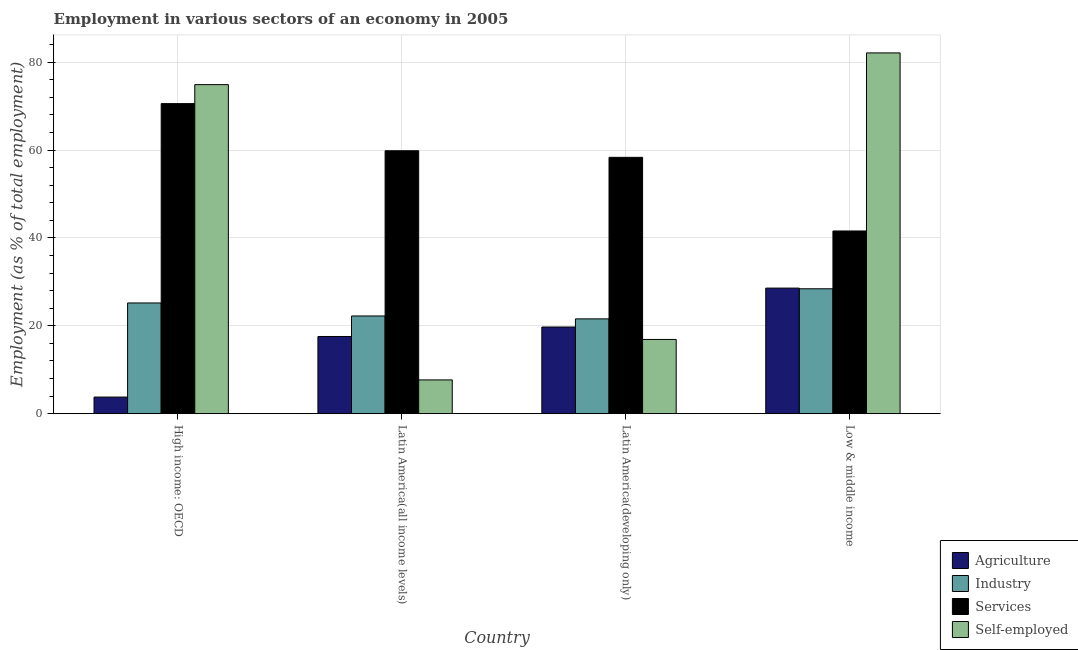How many groups of bars are there?
Provide a short and direct response. 4. How many bars are there on the 4th tick from the left?
Offer a very short reply. 4. What is the label of the 3rd group of bars from the left?
Your answer should be very brief. Latin America(developing only). In how many cases, is the number of bars for a given country not equal to the number of legend labels?
Make the answer very short. 0. What is the percentage of workers in industry in Latin America(all income levels)?
Make the answer very short. 22.24. Across all countries, what is the maximum percentage of workers in agriculture?
Offer a very short reply. 28.58. Across all countries, what is the minimum percentage of workers in services?
Give a very brief answer. 41.58. In which country was the percentage of workers in agriculture maximum?
Offer a terse response. Low & middle income. In which country was the percentage of workers in agriculture minimum?
Offer a terse response. High income: OECD. What is the total percentage of workers in industry in the graph?
Offer a terse response. 97.46. What is the difference between the percentage of self employed workers in Latin America(all income levels) and that in Latin America(developing only)?
Make the answer very short. -9.21. What is the difference between the percentage of workers in industry in High income: OECD and the percentage of workers in agriculture in Latin America(all income levels)?
Provide a short and direct response. 7.63. What is the average percentage of workers in services per country?
Your answer should be very brief. 57.58. What is the difference between the percentage of self employed workers and percentage of workers in services in High income: OECD?
Ensure brevity in your answer.  4.32. In how many countries, is the percentage of workers in agriculture greater than 36 %?
Keep it short and to the point. 0. What is the ratio of the percentage of workers in industry in Latin America(all income levels) to that in Latin America(developing only)?
Give a very brief answer. 1.03. Is the difference between the percentage of self employed workers in High income: OECD and Latin America(developing only) greater than the difference between the percentage of workers in services in High income: OECD and Latin America(developing only)?
Provide a succinct answer. Yes. What is the difference between the highest and the second highest percentage of workers in industry?
Offer a very short reply. 3.23. What is the difference between the highest and the lowest percentage of workers in services?
Offer a very short reply. 28.98. Is the sum of the percentage of workers in services in Latin America(all income levels) and Low & middle income greater than the maximum percentage of workers in agriculture across all countries?
Your answer should be very brief. Yes. Is it the case that in every country, the sum of the percentage of workers in industry and percentage of workers in services is greater than the sum of percentage of workers in agriculture and percentage of self employed workers?
Keep it short and to the point. No. What does the 3rd bar from the left in Low & middle income represents?
Ensure brevity in your answer.  Services. What does the 3rd bar from the right in Latin America(developing only) represents?
Provide a succinct answer. Industry. Is it the case that in every country, the sum of the percentage of workers in agriculture and percentage of workers in industry is greater than the percentage of workers in services?
Provide a short and direct response. No. How many bars are there?
Provide a short and direct response. 16. Are all the bars in the graph horizontal?
Make the answer very short. No. How many countries are there in the graph?
Make the answer very short. 4. What is the difference between two consecutive major ticks on the Y-axis?
Ensure brevity in your answer.  20. Does the graph contain any zero values?
Provide a succinct answer. No. How many legend labels are there?
Keep it short and to the point. 4. What is the title of the graph?
Keep it short and to the point. Employment in various sectors of an economy in 2005. What is the label or title of the Y-axis?
Make the answer very short. Employment (as % of total employment). What is the Employment (as % of total employment) in Agriculture in High income: OECD?
Ensure brevity in your answer.  3.79. What is the Employment (as % of total employment) of Industry in High income: OECD?
Ensure brevity in your answer.  25.2. What is the Employment (as % of total employment) of Services in High income: OECD?
Give a very brief answer. 70.56. What is the Employment (as % of total employment) of Self-employed in High income: OECD?
Provide a short and direct response. 74.88. What is the Employment (as % of total employment) of Agriculture in Latin America(all income levels)?
Provide a succinct answer. 17.58. What is the Employment (as % of total employment) of Industry in Latin America(all income levels)?
Keep it short and to the point. 22.24. What is the Employment (as % of total employment) in Services in Latin America(all income levels)?
Give a very brief answer. 59.84. What is the Employment (as % of total employment) of Self-employed in Latin America(all income levels)?
Your answer should be compact. 7.69. What is the Employment (as % of total employment) in Agriculture in Latin America(developing only)?
Your response must be concise. 19.73. What is the Employment (as % of total employment) of Industry in Latin America(developing only)?
Give a very brief answer. 21.59. What is the Employment (as % of total employment) in Services in Latin America(developing only)?
Your answer should be compact. 58.34. What is the Employment (as % of total employment) in Self-employed in Latin America(developing only)?
Provide a succinct answer. 16.9. What is the Employment (as % of total employment) of Agriculture in Low & middle income?
Keep it short and to the point. 28.58. What is the Employment (as % of total employment) of Industry in Low & middle income?
Your answer should be compact. 28.43. What is the Employment (as % of total employment) of Services in Low & middle income?
Offer a terse response. 41.58. What is the Employment (as % of total employment) of Self-employed in Low & middle income?
Your answer should be compact. 82.1. Across all countries, what is the maximum Employment (as % of total employment) in Agriculture?
Keep it short and to the point. 28.58. Across all countries, what is the maximum Employment (as % of total employment) in Industry?
Keep it short and to the point. 28.43. Across all countries, what is the maximum Employment (as % of total employment) of Services?
Your response must be concise. 70.56. Across all countries, what is the maximum Employment (as % of total employment) in Self-employed?
Provide a short and direct response. 82.1. Across all countries, what is the minimum Employment (as % of total employment) of Agriculture?
Keep it short and to the point. 3.79. Across all countries, what is the minimum Employment (as % of total employment) of Industry?
Your answer should be very brief. 21.59. Across all countries, what is the minimum Employment (as % of total employment) in Services?
Offer a terse response. 41.58. Across all countries, what is the minimum Employment (as % of total employment) in Self-employed?
Keep it short and to the point. 7.69. What is the total Employment (as % of total employment) in Agriculture in the graph?
Offer a terse response. 69.69. What is the total Employment (as % of total employment) of Industry in the graph?
Keep it short and to the point. 97.46. What is the total Employment (as % of total employment) in Services in the graph?
Keep it short and to the point. 230.32. What is the total Employment (as % of total employment) of Self-employed in the graph?
Your response must be concise. 181.58. What is the difference between the Employment (as % of total employment) in Agriculture in High income: OECD and that in Latin America(all income levels)?
Ensure brevity in your answer.  -13.78. What is the difference between the Employment (as % of total employment) of Industry in High income: OECD and that in Latin America(all income levels)?
Offer a very short reply. 2.96. What is the difference between the Employment (as % of total employment) of Services in High income: OECD and that in Latin America(all income levels)?
Give a very brief answer. 10.72. What is the difference between the Employment (as % of total employment) of Self-employed in High income: OECD and that in Latin America(all income levels)?
Provide a succinct answer. 67.19. What is the difference between the Employment (as % of total employment) of Agriculture in High income: OECD and that in Latin America(developing only)?
Ensure brevity in your answer.  -15.94. What is the difference between the Employment (as % of total employment) in Industry in High income: OECD and that in Latin America(developing only)?
Offer a terse response. 3.62. What is the difference between the Employment (as % of total employment) of Services in High income: OECD and that in Latin America(developing only)?
Give a very brief answer. 12.22. What is the difference between the Employment (as % of total employment) in Self-employed in High income: OECD and that in Latin America(developing only)?
Your response must be concise. 57.98. What is the difference between the Employment (as % of total employment) in Agriculture in High income: OECD and that in Low & middle income?
Offer a terse response. -24.79. What is the difference between the Employment (as % of total employment) of Industry in High income: OECD and that in Low & middle income?
Your answer should be very brief. -3.23. What is the difference between the Employment (as % of total employment) in Services in High income: OECD and that in Low & middle income?
Provide a short and direct response. 28.98. What is the difference between the Employment (as % of total employment) in Self-employed in High income: OECD and that in Low & middle income?
Provide a succinct answer. -7.22. What is the difference between the Employment (as % of total employment) in Agriculture in Latin America(all income levels) and that in Latin America(developing only)?
Your response must be concise. -2.16. What is the difference between the Employment (as % of total employment) of Industry in Latin America(all income levels) and that in Latin America(developing only)?
Keep it short and to the point. 0.66. What is the difference between the Employment (as % of total employment) in Services in Latin America(all income levels) and that in Latin America(developing only)?
Make the answer very short. 1.5. What is the difference between the Employment (as % of total employment) of Self-employed in Latin America(all income levels) and that in Latin America(developing only)?
Provide a succinct answer. -9.21. What is the difference between the Employment (as % of total employment) of Agriculture in Latin America(all income levels) and that in Low & middle income?
Provide a succinct answer. -11.01. What is the difference between the Employment (as % of total employment) in Industry in Latin America(all income levels) and that in Low & middle income?
Your answer should be compact. -6.19. What is the difference between the Employment (as % of total employment) in Services in Latin America(all income levels) and that in Low & middle income?
Your answer should be compact. 18.25. What is the difference between the Employment (as % of total employment) of Self-employed in Latin America(all income levels) and that in Low & middle income?
Your response must be concise. -74.4. What is the difference between the Employment (as % of total employment) of Agriculture in Latin America(developing only) and that in Low & middle income?
Keep it short and to the point. -8.85. What is the difference between the Employment (as % of total employment) of Industry in Latin America(developing only) and that in Low & middle income?
Offer a terse response. -6.85. What is the difference between the Employment (as % of total employment) of Services in Latin America(developing only) and that in Low & middle income?
Offer a very short reply. 16.75. What is the difference between the Employment (as % of total employment) in Self-employed in Latin America(developing only) and that in Low & middle income?
Your answer should be very brief. -65.19. What is the difference between the Employment (as % of total employment) of Agriculture in High income: OECD and the Employment (as % of total employment) of Industry in Latin America(all income levels)?
Keep it short and to the point. -18.45. What is the difference between the Employment (as % of total employment) in Agriculture in High income: OECD and the Employment (as % of total employment) in Services in Latin America(all income levels)?
Your answer should be very brief. -56.04. What is the difference between the Employment (as % of total employment) of Agriculture in High income: OECD and the Employment (as % of total employment) of Self-employed in Latin America(all income levels)?
Offer a terse response. -3.9. What is the difference between the Employment (as % of total employment) in Industry in High income: OECD and the Employment (as % of total employment) in Services in Latin America(all income levels)?
Ensure brevity in your answer.  -34.63. What is the difference between the Employment (as % of total employment) in Industry in High income: OECD and the Employment (as % of total employment) in Self-employed in Latin America(all income levels)?
Your answer should be compact. 17.51. What is the difference between the Employment (as % of total employment) of Services in High income: OECD and the Employment (as % of total employment) of Self-employed in Latin America(all income levels)?
Your answer should be very brief. 62.87. What is the difference between the Employment (as % of total employment) in Agriculture in High income: OECD and the Employment (as % of total employment) in Industry in Latin America(developing only)?
Give a very brief answer. -17.79. What is the difference between the Employment (as % of total employment) of Agriculture in High income: OECD and the Employment (as % of total employment) of Services in Latin America(developing only)?
Offer a very short reply. -54.54. What is the difference between the Employment (as % of total employment) in Agriculture in High income: OECD and the Employment (as % of total employment) in Self-employed in Latin America(developing only)?
Offer a terse response. -13.11. What is the difference between the Employment (as % of total employment) of Industry in High income: OECD and the Employment (as % of total employment) of Services in Latin America(developing only)?
Keep it short and to the point. -33.13. What is the difference between the Employment (as % of total employment) of Industry in High income: OECD and the Employment (as % of total employment) of Self-employed in Latin America(developing only)?
Offer a terse response. 8.3. What is the difference between the Employment (as % of total employment) in Services in High income: OECD and the Employment (as % of total employment) in Self-employed in Latin America(developing only)?
Make the answer very short. 53.66. What is the difference between the Employment (as % of total employment) in Agriculture in High income: OECD and the Employment (as % of total employment) in Industry in Low & middle income?
Your response must be concise. -24.64. What is the difference between the Employment (as % of total employment) in Agriculture in High income: OECD and the Employment (as % of total employment) in Services in Low & middle income?
Your response must be concise. -37.79. What is the difference between the Employment (as % of total employment) of Agriculture in High income: OECD and the Employment (as % of total employment) of Self-employed in Low & middle income?
Your answer should be compact. -78.3. What is the difference between the Employment (as % of total employment) in Industry in High income: OECD and the Employment (as % of total employment) in Services in Low & middle income?
Ensure brevity in your answer.  -16.38. What is the difference between the Employment (as % of total employment) of Industry in High income: OECD and the Employment (as % of total employment) of Self-employed in Low & middle income?
Give a very brief answer. -56.89. What is the difference between the Employment (as % of total employment) in Services in High income: OECD and the Employment (as % of total employment) in Self-employed in Low & middle income?
Provide a short and direct response. -11.54. What is the difference between the Employment (as % of total employment) in Agriculture in Latin America(all income levels) and the Employment (as % of total employment) in Industry in Latin America(developing only)?
Keep it short and to the point. -4.01. What is the difference between the Employment (as % of total employment) in Agriculture in Latin America(all income levels) and the Employment (as % of total employment) in Services in Latin America(developing only)?
Your answer should be very brief. -40.76. What is the difference between the Employment (as % of total employment) in Agriculture in Latin America(all income levels) and the Employment (as % of total employment) in Self-employed in Latin America(developing only)?
Your response must be concise. 0.67. What is the difference between the Employment (as % of total employment) of Industry in Latin America(all income levels) and the Employment (as % of total employment) of Services in Latin America(developing only)?
Your response must be concise. -36.09. What is the difference between the Employment (as % of total employment) of Industry in Latin America(all income levels) and the Employment (as % of total employment) of Self-employed in Latin America(developing only)?
Your response must be concise. 5.34. What is the difference between the Employment (as % of total employment) in Services in Latin America(all income levels) and the Employment (as % of total employment) in Self-employed in Latin America(developing only)?
Make the answer very short. 42.93. What is the difference between the Employment (as % of total employment) of Agriculture in Latin America(all income levels) and the Employment (as % of total employment) of Industry in Low & middle income?
Offer a very short reply. -10.86. What is the difference between the Employment (as % of total employment) of Agriculture in Latin America(all income levels) and the Employment (as % of total employment) of Services in Low & middle income?
Make the answer very short. -24.01. What is the difference between the Employment (as % of total employment) of Agriculture in Latin America(all income levels) and the Employment (as % of total employment) of Self-employed in Low & middle income?
Ensure brevity in your answer.  -64.52. What is the difference between the Employment (as % of total employment) of Industry in Latin America(all income levels) and the Employment (as % of total employment) of Services in Low & middle income?
Offer a terse response. -19.34. What is the difference between the Employment (as % of total employment) in Industry in Latin America(all income levels) and the Employment (as % of total employment) in Self-employed in Low & middle income?
Your answer should be very brief. -59.85. What is the difference between the Employment (as % of total employment) in Services in Latin America(all income levels) and the Employment (as % of total employment) in Self-employed in Low & middle income?
Offer a terse response. -22.26. What is the difference between the Employment (as % of total employment) in Agriculture in Latin America(developing only) and the Employment (as % of total employment) in Industry in Low & middle income?
Give a very brief answer. -8.7. What is the difference between the Employment (as % of total employment) in Agriculture in Latin America(developing only) and the Employment (as % of total employment) in Services in Low & middle income?
Make the answer very short. -21.85. What is the difference between the Employment (as % of total employment) in Agriculture in Latin America(developing only) and the Employment (as % of total employment) in Self-employed in Low & middle income?
Provide a succinct answer. -62.36. What is the difference between the Employment (as % of total employment) of Industry in Latin America(developing only) and the Employment (as % of total employment) of Services in Low & middle income?
Your response must be concise. -20. What is the difference between the Employment (as % of total employment) of Industry in Latin America(developing only) and the Employment (as % of total employment) of Self-employed in Low & middle income?
Offer a very short reply. -60.51. What is the difference between the Employment (as % of total employment) of Services in Latin America(developing only) and the Employment (as % of total employment) of Self-employed in Low & middle income?
Ensure brevity in your answer.  -23.76. What is the average Employment (as % of total employment) of Agriculture per country?
Your answer should be compact. 17.42. What is the average Employment (as % of total employment) of Industry per country?
Your response must be concise. 24.37. What is the average Employment (as % of total employment) in Services per country?
Ensure brevity in your answer.  57.58. What is the average Employment (as % of total employment) in Self-employed per country?
Your response must be concise. 45.39. What is the difference between the Employment (as % of total employment) of Agriculture and Employment (as % of total employment) of Industry in High income: OECD?
Keep it short and to the point. -21.41. What is the difference between the Employment (as % of total employment) of Agriculture and Employment (as % of total employment) of Services in High income: OECD?
Your answer should be very brief. -66.77. What is the difference between the Employment (as % of total employment) in Agriculture and Employment (as % of total employment) in Self-employed in High income: OECD?
Provide a short and direct response. -71.09. What is the difference between the Employment (as % of total employment) of Industry and Employment (as % of total employment) of Services in High income: OECD?
Your response must be concise. -45.36. What is the difference between the Employment (as % of total employment) in Industry and Employment (as % of total employment) in Self-employed in High income: OECD?
Your answer should be compact. -49.68. What is the difference between the Employment (as % of total employment) of Services and Employment (as % of total employment) of Self-employed in High income: OECD?
Ensure brevity in your answer.  -4.32. What is the difference between the Employment (as % of total employment) in Agriculture and Employment (as % of total employment) in Industry in Latin America(all income levels)?
Provide a succinct answer. -4.67. What is the difference between the Employment (as % of total employment) in Agriculture and Employment (as % of total employment) in Services in Latin America(all income levels)?
Your answer should be compact. -42.26. What is the difference between the Employment (as % of total employment) of Agriculture and Employment (as % of total employment) of Self-employed in Latin America(all income levels)?
Your answer should be compact. 9.88. What is the difference between the Employment (as % of total employment) in Industry and Employment (as % of total employment) in Services in Latin America(all income levels)?
Your answer should be very brief. -37.59. What is the difference between the Employment (as % of total employment) of Industry and Employment (as % of total employment) of Self-employed in Latin America(all income levels)?
Your response must be concise. 14.55. What is the difference between the Employment (as % of total employment) of Services and Employment (as % of total employment) of Self-employed in Latin America(all income levels)?
Provide a short and direct response. 52.14. What is the difference between the Employment (as % of total employment) in Agriculture and Employment (as % of total employment) in Industry in Latin America(developing only)?
Offer a very short reply. -1.85. What is the difference between the Employment (as % of total employment) in Agriculture and Employment (as % of total employment) in Services in Latin America(developing only)?
Your response must be concise. -38.6. What is the difference between the Employment (as % of total employment) of Agriculture and Employment (as % of total employment) of Self-employed in Latin America(developing only)?
Your answer should be compact. 2.83. What is the difference between the Employment (as % of total employment) in Industry and Employment (as % of total employment) in Services in Latin America(developing only)?
Keep it short and to the point. -36.75. What is the difference between the Employment (as % of total employment) in Industry and Employment (as % of total employment) in Self-employed in Latin America(developing only)?
Your answer should be compact. 4.68. What is the difference between the Employment (as % of total employment) of Services and Employment (as % of total employment) of Self-employed in Latin America(developing only)?
Keep it short and to the point. 41.43. What is the difference between the Employment (as % of total employment) of Agriculture and Employment (as % of total employment) of Industry in Low & middle income?
Offer a terse response. 0.15. What is the difference between the Employment (as % of total employment) in Agriculture and Employment (as % of total employment) in Services in Low & middle income?
Keep it short and to the point. -13. What is the difference between the Employment (as % of total employment) in Agriculture and Employment (as % of total employment) in Self-employed in Low & middle income?
Make the answer very short. -53.51. What is the difference between the Employment (as % of total employment) in Industry and Employment (as % of total employment) in Services in Low & middle income?
Make the answer very short. -13.15. What is the difference between the Employment (as % of total employment) of Industry and Employment (as % of total employment) of Self-employed in Low & middle income?
Your answer should be compact. -53.67. What is the difference between the Employment (as % of total employment) in Services and Employment (as % of total employment) in Self-employed in Low & middle income?
Provide a succinct answer. -40.51. What is the ratio of the Employment (as % of total employment) of Agriculture in High income: OECD to that in Latin America(all income levels)?
Make the answer very short. 0.22. What is the ratio of the Employment (as % of total employment) of Industry in High income: OECD to that in Latin America(all income levels)?
Keep it short and to the point. 1.13. What is the ratio of the Employment (as % of total employment) in Services in High income: OECD to that in Latin America(all income levels)?
Your answer should be compact. 1.18. What is the ratio of the Employment (as % of total employment) in Self-employed in High income: OECD to that in Latin America(all income levels)?
Keep it short and to the point. 9.73. What is the ratio of the Employment (as % of total employment) of Agriculture in High income: OECD to that in Latin America(developing only)?
Give a very brief answer. 0.19. What is the ratio of the Employment (as % of total employment) of Industry in High income: OECD to that in Latin America(developing only)?
Give a very brief answer. 1.17. What is the ratio of the Employment (as % of total employment) of Services in High income: OECD to that in Latin America(developing only)?
Your answer should be very brief. 1.21. What is the ratio of the Employment (as % of total employment) of Self-employed in High income: OECD to that in Latin America(developing only)?
Provide a succinct answer. 4.43. What is the ratio of the Employment (as % of total employment) in Agriculture in High income: OECD to that in Low & middle income?
Ensure brevity in your answer.  0.13. What is the ratio of the Employment (as % of total employment) in Industry in High income: OECD to that in Low & middle income?
Provide a succinct answer. 0.89. What is the ratio of the Employment (as % of total employment) of Services in High income: OECD to that in Low & middle income?
Keep it short and to the point. 1.7. What is the ratio of the Employment (as % of total employment) in Self-employed in High income: OECD to that in Low & middle income?
Provide a succinct answer. 0.91. What is the ratio of the Employment (as % of total employment) of Agriculture in Latin America(all income levels) to that in Latin America(developing only)?
Give a very brief answer. 0.89. What is the ratio of the Employment (as % of total employment) of Industry in Latin America(all income levels) to that in Latin America(developing only)?
Provide a succinct answer. 1.03. What is the ratio of the Employment (as % of total employment) in Services in Latin America(all income levels) to that in Latin America(developing only)?
Ensure brevity in your answer.  1.03. What is the ratio of the Employment (as % of total employment) in Self-employed in Latin America(all income levels) to that in Latin America(developing only)?
Provide a short and direct response. 0.46. What is the ratio of the Employment (as % of total employment) in Agriculture in Latin America(all income levels) to that in Low & middle income?
Give a very brief answer. 0.61. What is the ratio of the Employment (as % of total employment) in Industry in Latin America(all income levels) to that in Low & middle income?
Provide a succinct answer. 0.78. What is the ratio of the Employment (as % of total employment) of Services in Latin America(all income levels) to that in Low & middle income?
Provide a succinct answer. 1.44. What is the ratio of the Employment (as % of total employment) in Self-employed in Latin America(all income levels) to that in Low & middle income?
Give a very brief answer. 0.09. What is the ratio of the Employment (as % of total employment) of Agriculture in Latin America(developing only) to that in Low & middle income?
Ensure brevity in your answer.  0.69. What is the ratio of the Employment (as % of total employment) of Industry in Latin America(developing only) to that in Low & middle income?
Provide a succinct answer. 0.76. What is the ratio of the Employment (as % of total employment) in Services in Latin America(developing only) to that in Low & middle income?
Provide a short and direct response. 1.4. What is the ratio of the Employment (as % of total employment) of Self-employed in Latin America(developing only) to that in Low & middle income?
Keep it short and to the point. 0.21. What is the difference between the highest and the second highest Employment (as % of total employment) in Agriculture?
Make the answer very short. 8.85. What is the difference between the highest and the second highest Employment (as % of total employment) of Industry?
Provide a short and direct response. 3.23. What is the difference between the highest and the second highest Employment (as % of total employment) in Services?
Your response must be concise. 10.72. What is the difference between the highest and the second highest Employment (as % of total employment) in Self-employed?
Give a very brief answer. 7.22. What is the difference between the highest and the lowest Employment (as % of total employment) of Agriculture?
Offer a terse response. 24.79. What is the difference between the highest and the lowest Employment (as % of total employment) of Industry?
Your answer should be very brief. 6.85. What is the difference between the highest and the lowest Employment (as % of total employment) in Services?
Ensure brevity in your answer.  28.98. What is the difference between the highest and the lowest Employment (as % of total employment) in Self-employed?
Your answer should be very brief. 74.4. 